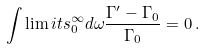<formula> <loc_0><loc_0><loc_500><loc_500>\int \lim i t s _ { 0 } ^ { \infty } d \omega \frac { \Gamma ^ { \prime } - \Gamma _ { 0 } } { \Gamma _ { 0 } } = 0 \, .</formula> 